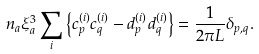<formula> <loc_0><loc_0><loc_500><loc_500>n _ { a } \xi _ { a } ^ { 3 } \sum _ { i } \left \{ c _ { p } ^ { ( i ) } c _ { q } ^ { ( i ) } - d _ { p } ^ { ( i ) } d _ { q } ^ { ( i ) } \right \} = \frac { 1 } { 2 \pi L } \delta _ { { p } , { q } } .</formula> 